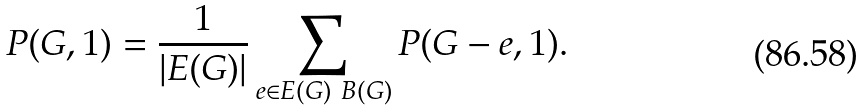Convert formula to latex. <formula><loc_0><loc_0><loc_500><loc_500>P ( G , 1 ) = \frac { 1 } { | E ( G ) | } \sum _ { e \in E ( G ) \ B ( G ) } P ( G - e , 1 ) .</formula> 